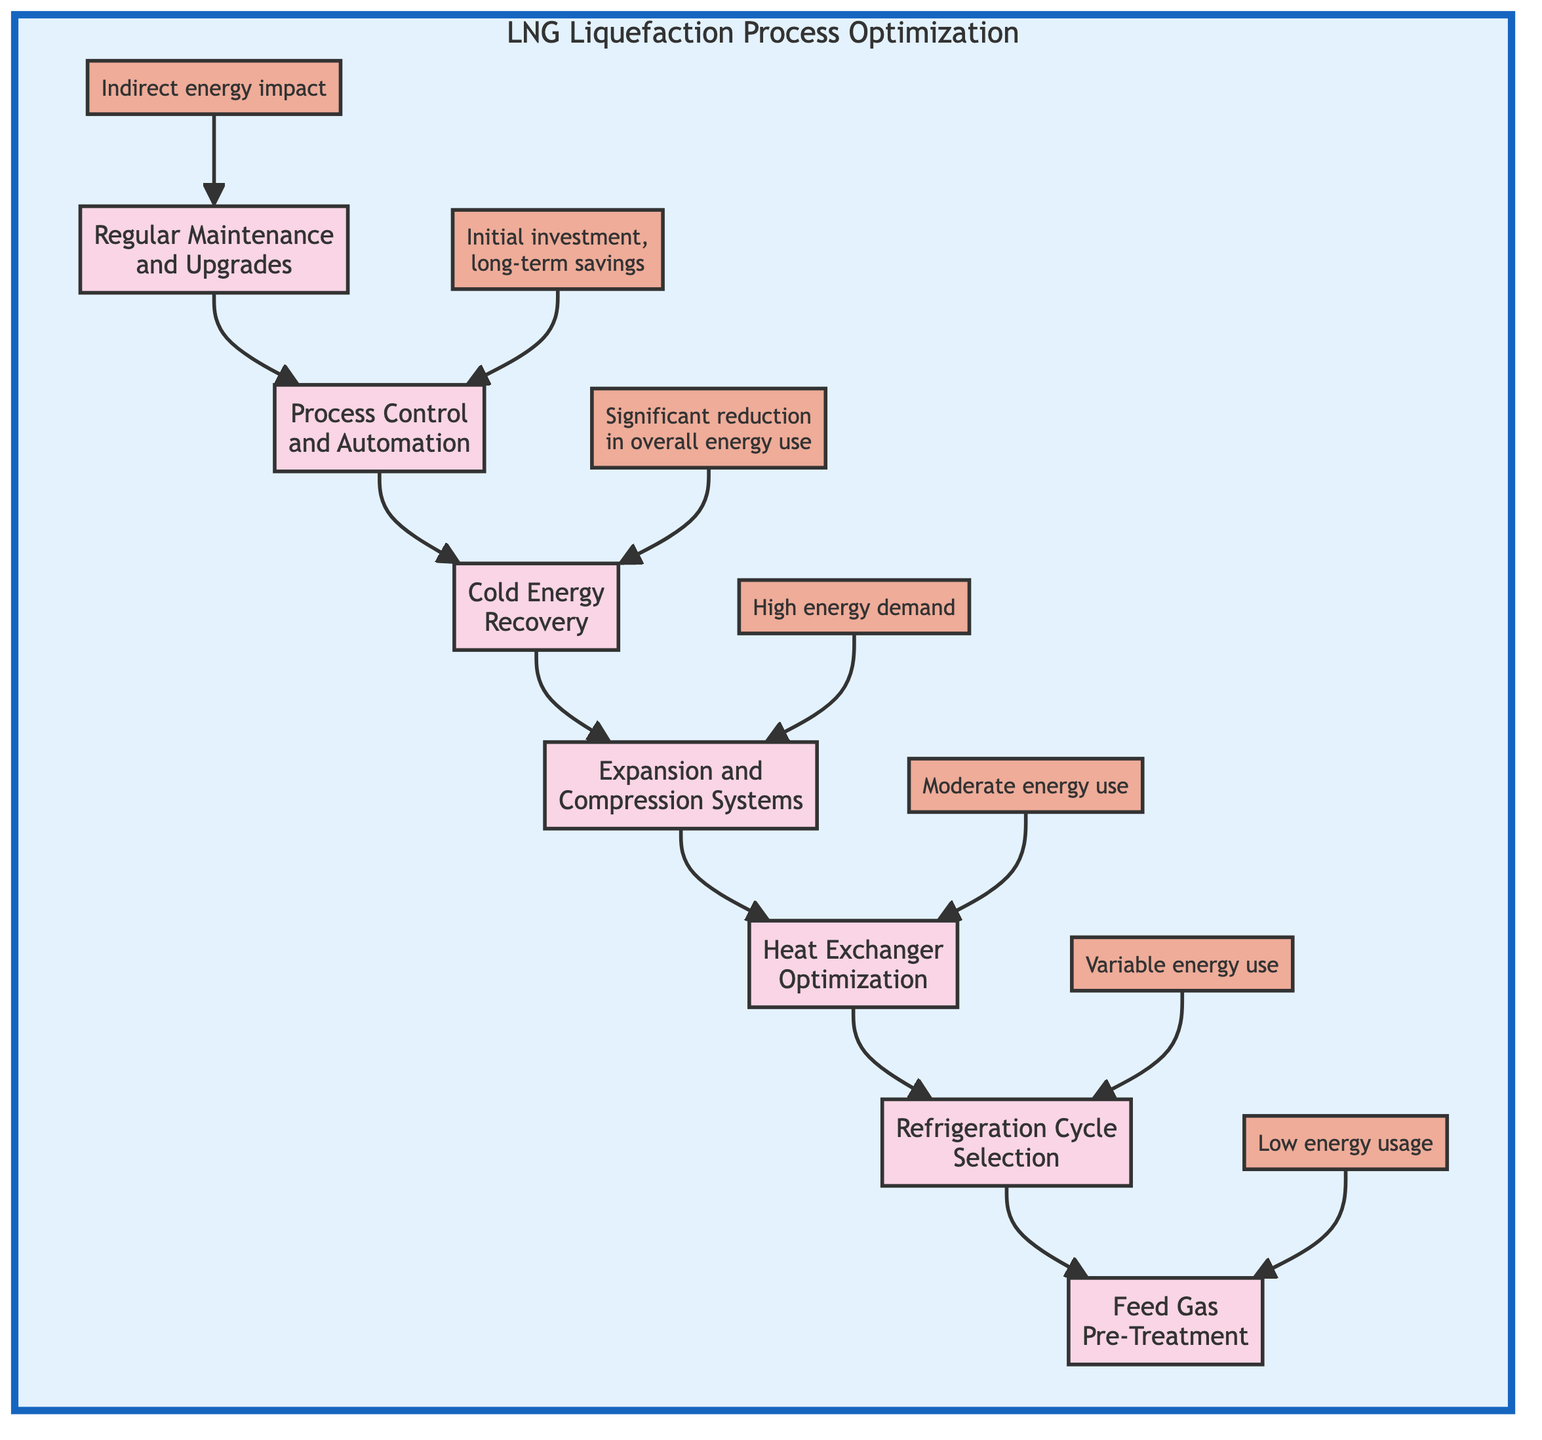What is the first step in the LNG liquefaction optimization process? The first step in the process, as indicated at the base of the flowchart, is "Regular Maintenance and Upgrades". It sets the stage for the entire optimization process.
Answer: Regular Maintenance and Upgrades How many main steps are shown in the LNG liquefaction process? By counting each node indicating a step in the process from the given diagram, there are a total of six main steps articulated in the chart.
Answer: Six What type of energy consumption is associated with Cold Energy Recovery? As per the diagram, the type of energy consumption associated with Cold Energy Recovery is "Significant reduction in overall energy use through effective recovery methods.". This reflects a positive impact on energy efficiency.
Answer: Significant reduction in overall energy use Which step comes after Heat Exchanger Optimization? Tracing the flow of the diagram, Heat Exchanger Optimization is followed directly by Refrigeration Cycle Selection, continuing the pathway for optimization.
Answer: Refrigeration Cycle Selection What is the energy consumption level for Feed Gas Pre-Treatment? For Feed Gas Pre-Treatment, it is specified that the energy consumption level is "Low energy usage for scrubbing and drying processes," indicating its efficiency in the overall scheme.
Answer: Low energy usage What is the overall energy impact of Process Control and Automation? The overall energy impact of Process Control and Automation is described as "Initial investment in sensors and software, but long-term energy savings." This highlights its importance in long-term optimizations.
Answer: Initial investment, long-term savings Which step directly feeds into Feed Gas Pre-Treatment? The step that feeds directly into Feed Gas Pre-Treatment is Refrigeration Cycle Selection, emphasizing the sequential processing of the liquefaction steps.
Answer: Refrigeration Cycle Selection What type of energy consumption is indicated for Expansion and Compression Systems? The energy consumption described for Expansion and Compression Systems is categorized as "High energy demand," pointing to significant energy usage in that phase of the process.
Answer: High energy demand 